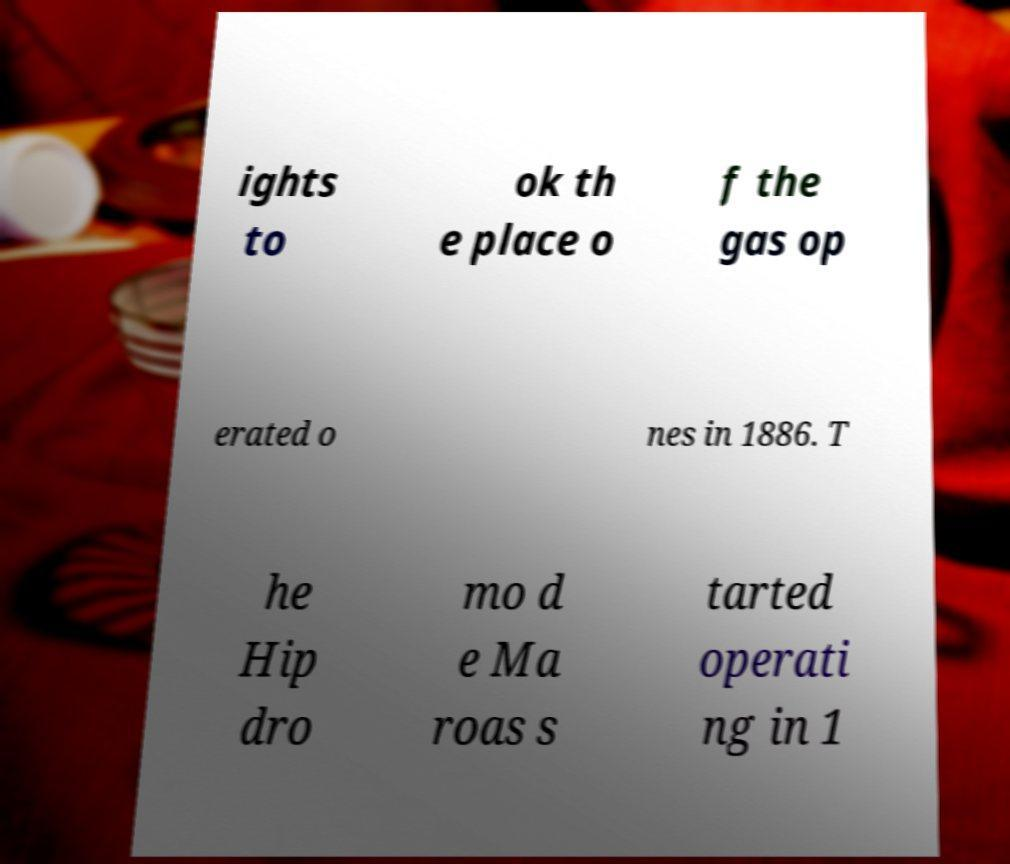I need the written content from this picture converted into text. Can you do that? ights to ok th e place o f the gas op erated o nes in 1886. T he Hip dro mo d e Ma roas s tarted operati ng in 1 